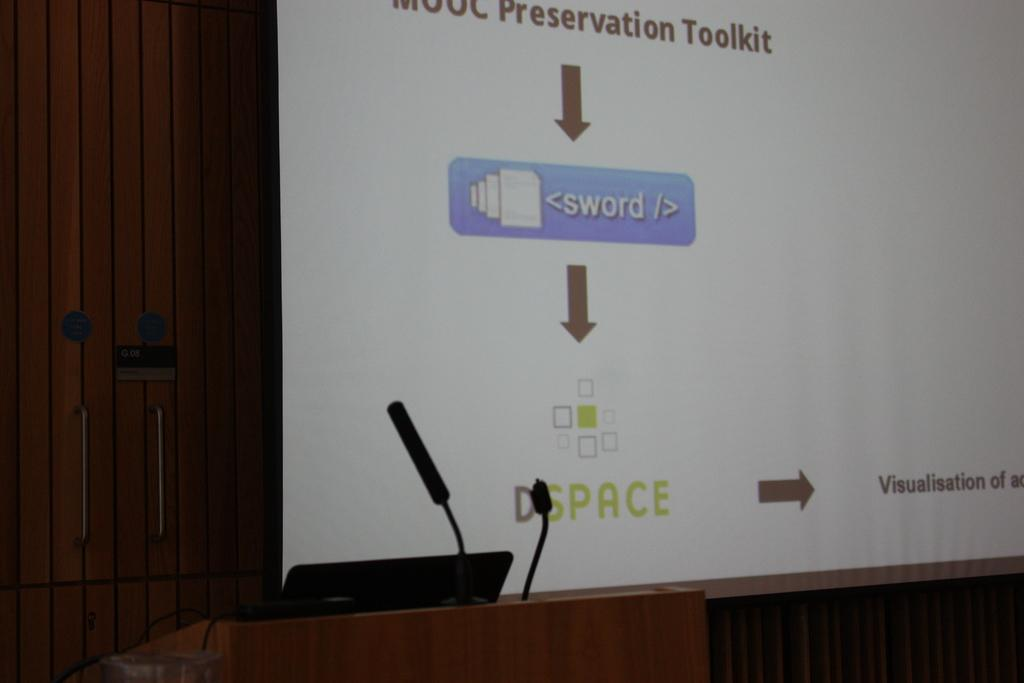What is the main object on the podium in the image? There are microphones on the podium in the image. What other device is present on the podium? There is a laptop on the podium. What can be seen in the background of the image? There is a wooden door and a screen in the background of the image. What is displayed on the screen? Text is visible on the screen. What type of shoes can be seen on the podium? There are no shoes present on the podium in the image. Is there a lamp illuminating the podium? There is no lamp visible in the image. 